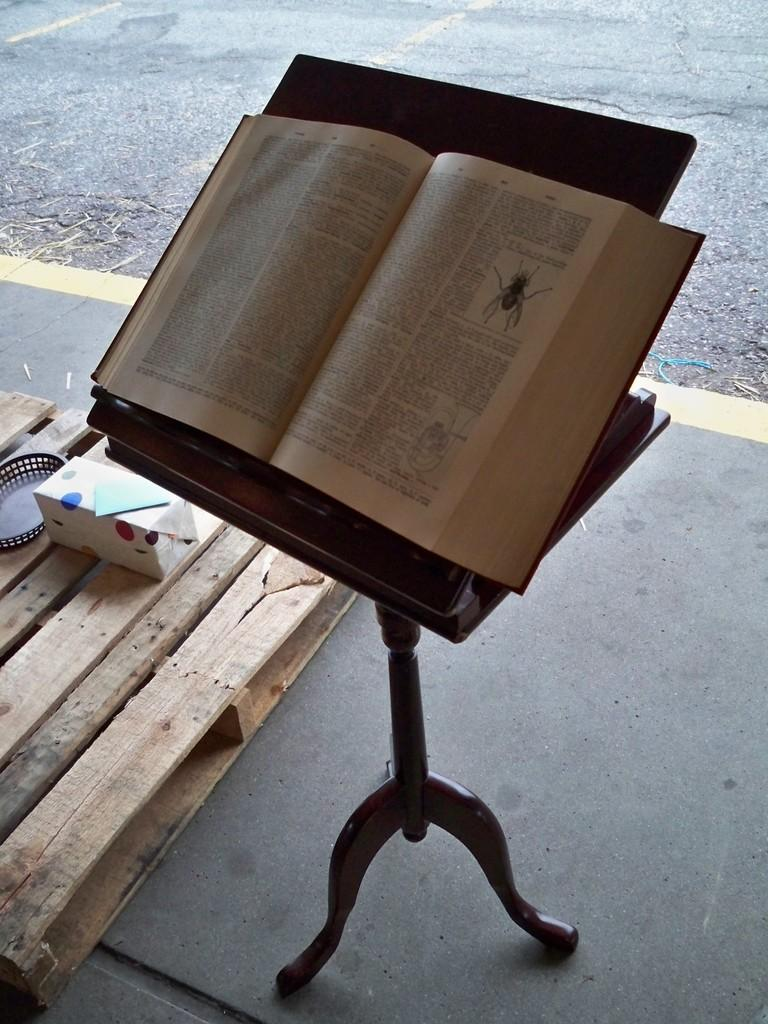What is placed on a stand in the image? There is a book on a stand in the image. What can be found on a table in the image? There is gift wrap on a table in the image. What type of surface is visible in the image? There is a road visible in the image. What type of fuel is being used by the vein in the image? There is no vein or fuel present in the image. How does the air interact with the gift wrap in the image? The air does not interact with the gift wrap in the image; it is a static object on a table. 